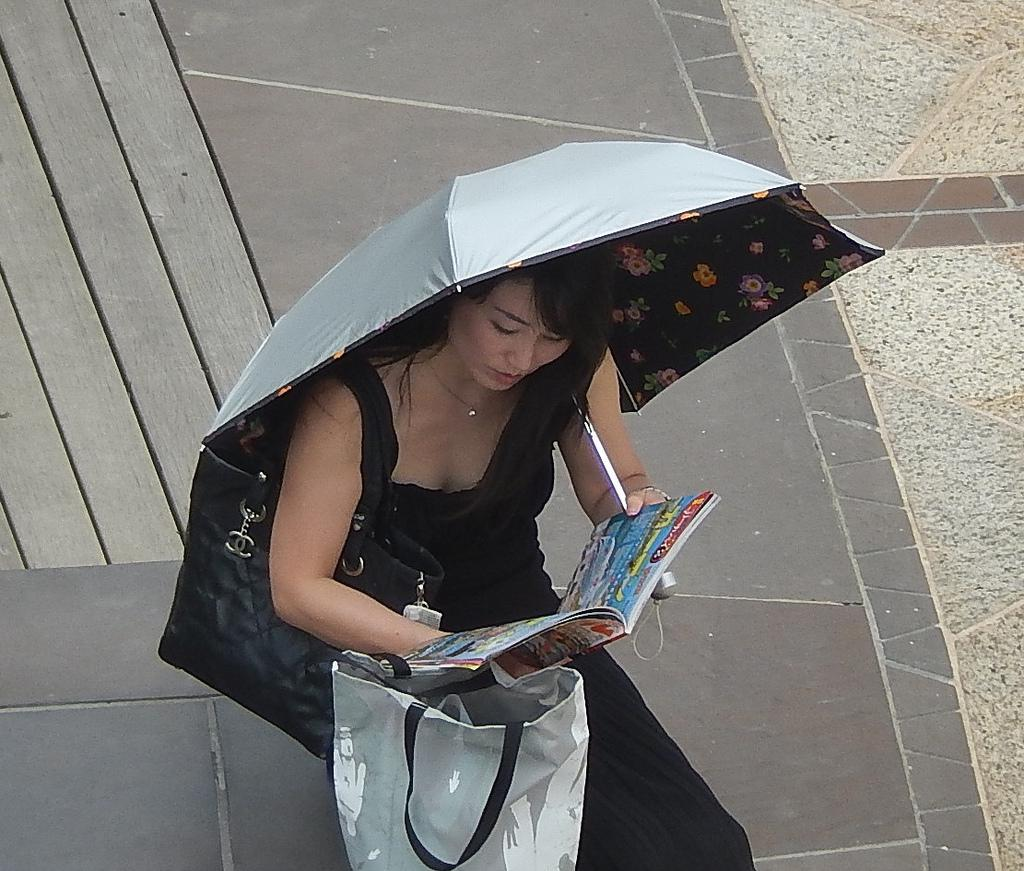Question: what is in the woman's hands?
Choices:
A. A novel.
B. A laptop.
C. A magazine.
D. A box.
Answer with the letter. Answer: C Question: how many bags is the woman holding?
Choices:
A. One.
B. Three.
C. Two bags.
D. Five.
Answer with the letter. Answer: C Question: what is behind the woman?
Choices:
A. An umbrella.
B. A television.
C. A door.
D. A bookshelf.
Answer with the letter. Answer: A Question: what is around the woman's neck?
Choices:
A. A shirt collar.
B. Bandages.
C. A necklace.
D. A brace.
Answer with the letter. Answer: C Question: what is white with black straps?
Choices:
A. The cloth.
B. The book.
C. The other bag.
D. The painting.
Answer with the letter. Answer: C Question: how many bags are there?
Choices:
A. Three.
B. Four.
C. Two.
D. Five.
Answer with the letter. Answer: C Question: what is she reading?
Choices:
A. A newspaper.
B. A book.
C. A magazine.
D. A poem.
Answer with the letter. Answer: C Question: who is wearing a necklace?
Choices:
A. The man.
B. The woman.
C. The girl.
D. The teacher.
Answer with the letter. Answer: B Question: what is the ground made from?
Choices:
A. Brick.
B. Stone tiles and wooden planks.
C. Ceramic tiles.
D. Concrete and brick.
Answer with the letter. Answer: B Question: who has a black leather purse?
Choices:
A. The girl.
B. The man.
C. The teenager.
D. The woman.
Answer with the letter. Answer: D Question: what colors are in the tote?
Choices:
A. Red and green.
B. Yellow and purple.
C. Grey and white.
D. Blue and purple.
Answer with the letter. Answer: C Question: who has a magazine and umbrella?
Choices:
A. The man.
B. The woman.
C. The girl.
D. The gentleman.
Answer with the letter. Answer: B Question: what kind of bags does the woman have?
Choices:
A. A lunch bag.
B. She has a purse and a shopping bag.
C. A sandwich bag.
D. A suitcase.
Answer with the letter. Answer: B Question: why does the woman have an umbrella?
Choices:
A. Skin protection.
B. Sun protection.
C. Heat reduction.
D. Style.
Answer with the letter. Answer: B 